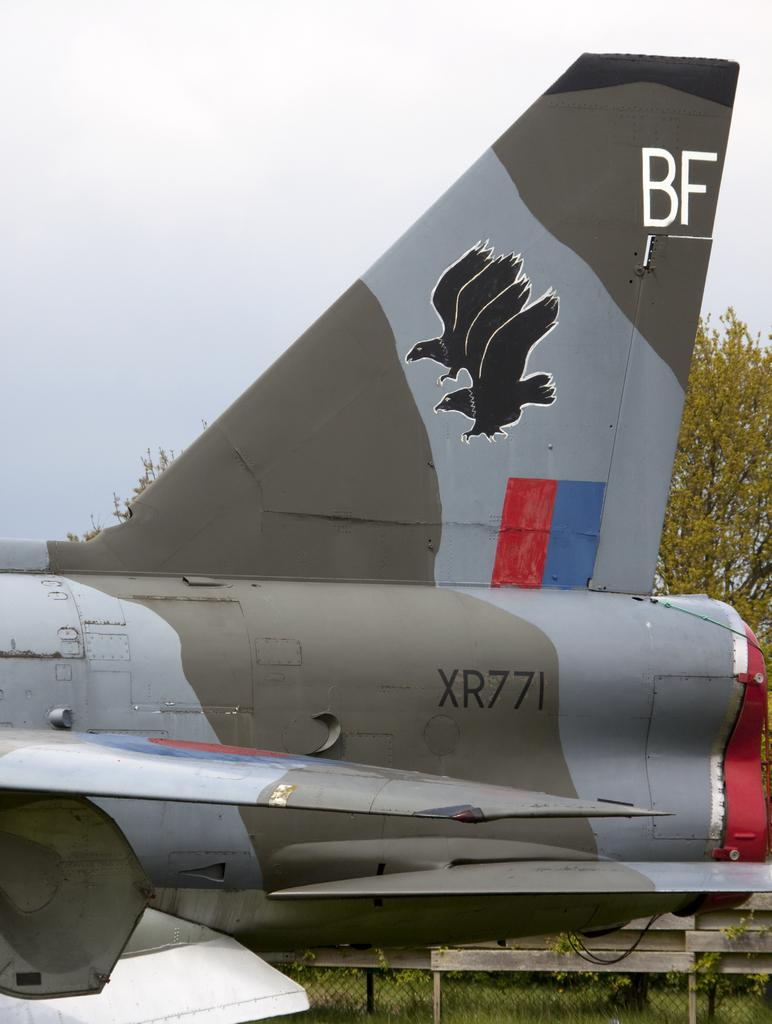<image>
Render a clear and concise summary of the photo. A plane with the letters BF on the tail is parked. 